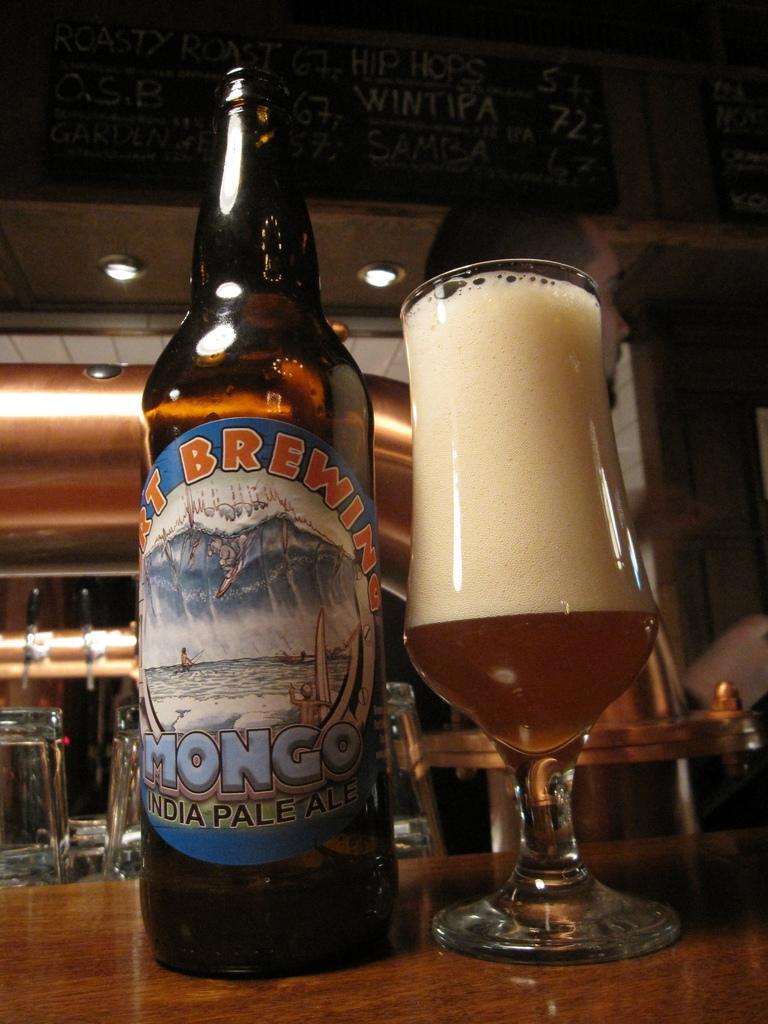What type of beverage is present in the image? There is beer in the image, both in a bottle and a glass. Where are the beer bottle and glass located? The beer bottle and glass are placed on a table. Is there any text visible in the image? Yes, there is a name board at the top of the image. How many beds are visible in the image? There are no beds present in the image. What type of feather can be seen in the image? There is no feather present in the image. 